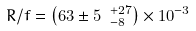<formula> <loc_0><loc_0><loc_500><loc_500>R / f = \left ( 6 3 \pm 5 \ ^ { + 2 7 } _ { - 8 } \right ) \times 1 0 ^ { - 3 }</formula> 